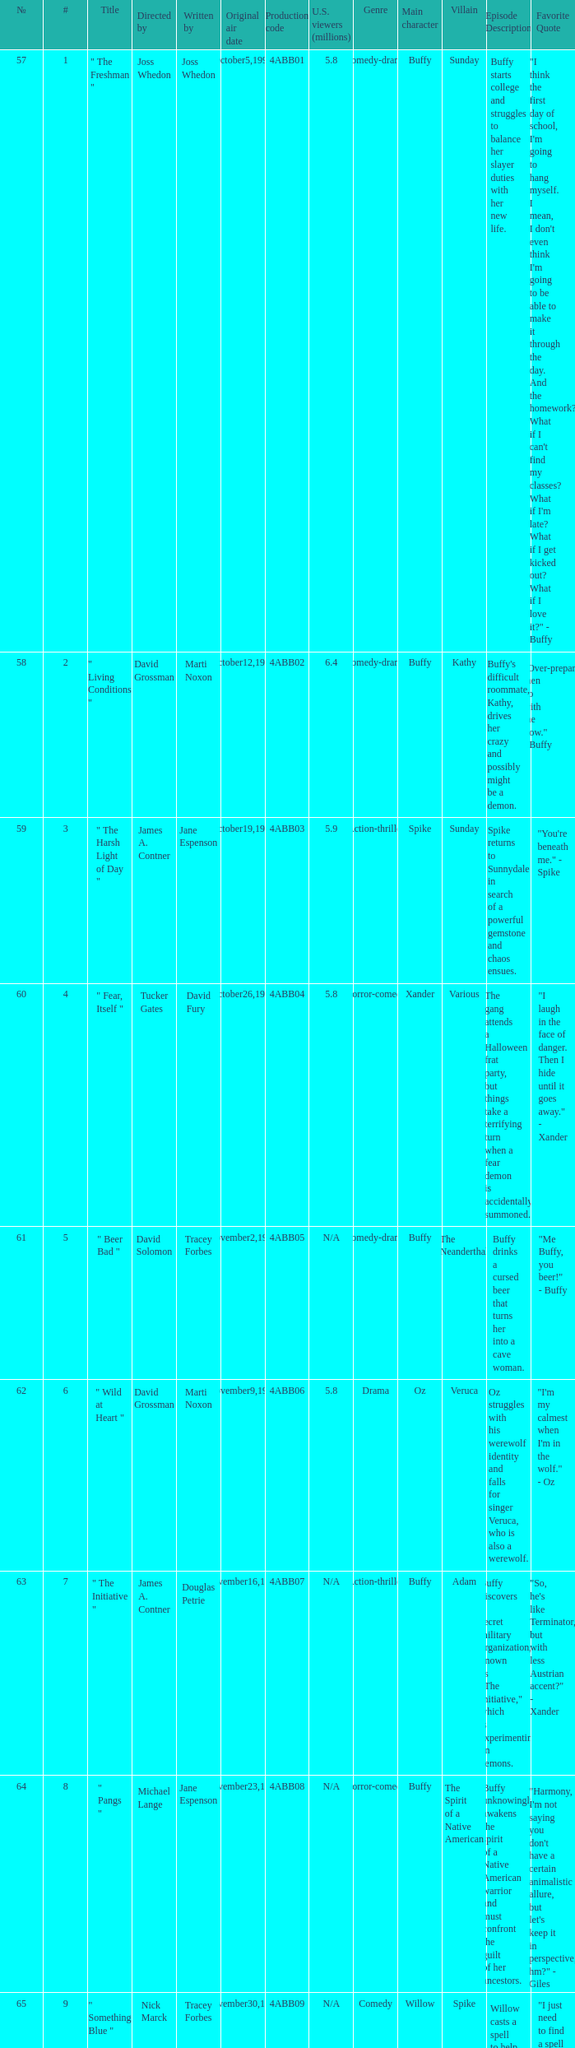What is the series No when the season 4 # is 18? 74.0. 